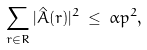<formula> <loc_0><loc_0><loc_500><loc_500>\sum _ { r \in R } | \hat { A } ( r ) | ^ { 2 } \, \leq \, \alpha p ^ { 2 } ,</formula> 